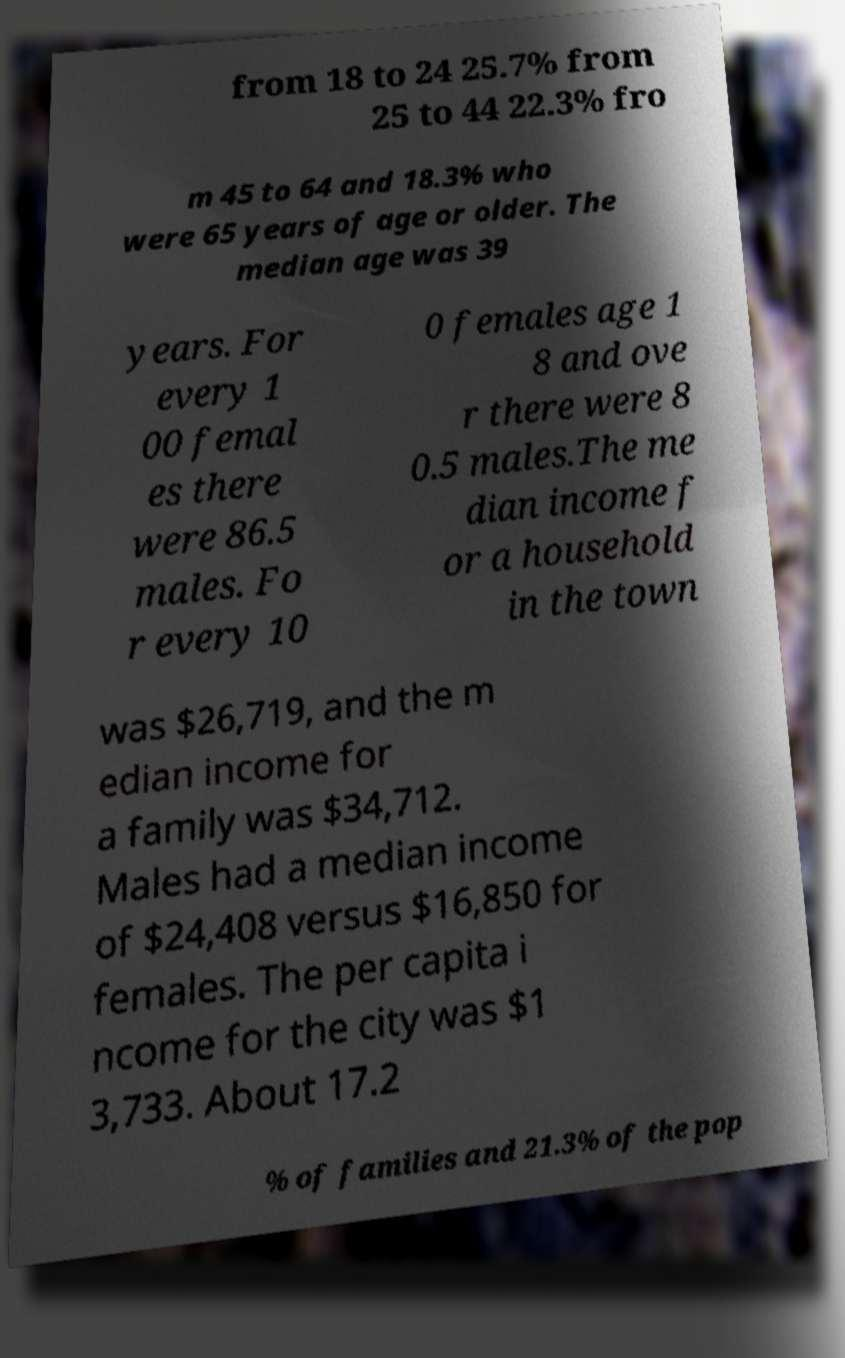Could you extract and type out the text from this image? from 18 to 24 25.7% from 25 to 44 22.3% fro m 45 to 64 and 18.3% who were 65 years of age or older. The median age was 39 years. For every 1 00 femal es there were 86.5 males. Fo r every 10 0 females age 1 8 and ove r there were 8 0.5 males.The me dian income f or a household in the town was $26,719, and the m edian income for a family was $34,712. Males had a median income of $24,408 versus $16,850 for females. The per capita i ncome for the city was $1 3,733. About 17.2 % of families and 21.3% of the pop 